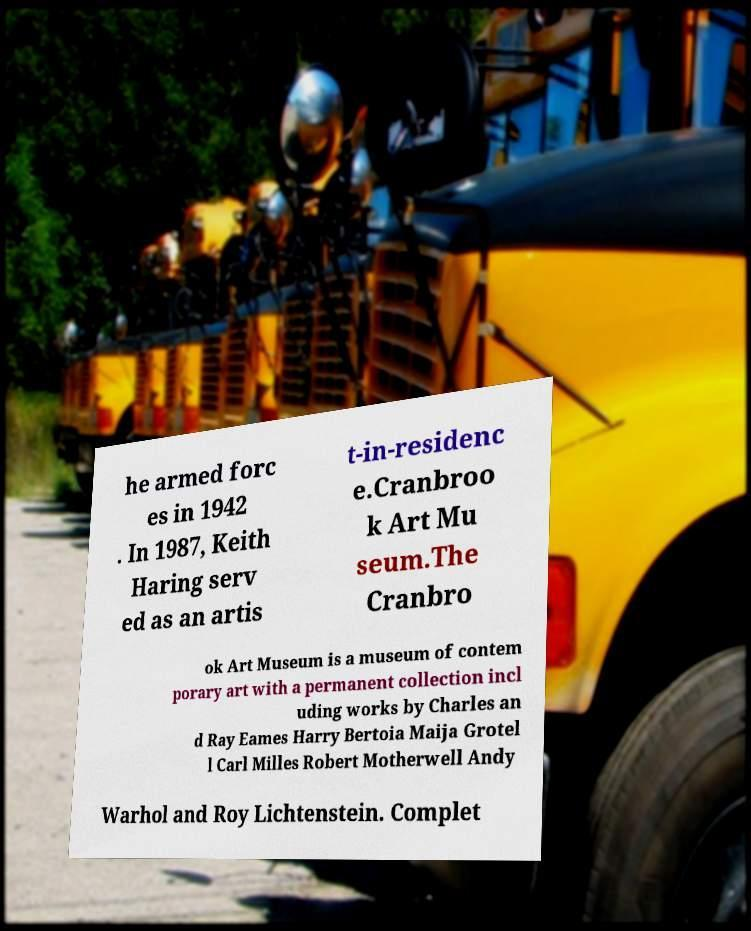For documentation purposes, I need the text within this image transcribed. Could you provide that? he armed forc es in 1942 . In 1987, Keith Haring serv ed as an artis t-in-residenc e.Cranbroo k Art Mu seum.The Cranbro ok Art Museum is a museum of contem porary art with a permanent collection incl uding works by Charles an d Ray Eames Harry Bertoia Maija Grotel l Carl Milles Robert Motherwell Andy Warhol and Roy Lichtenstein. Complet 